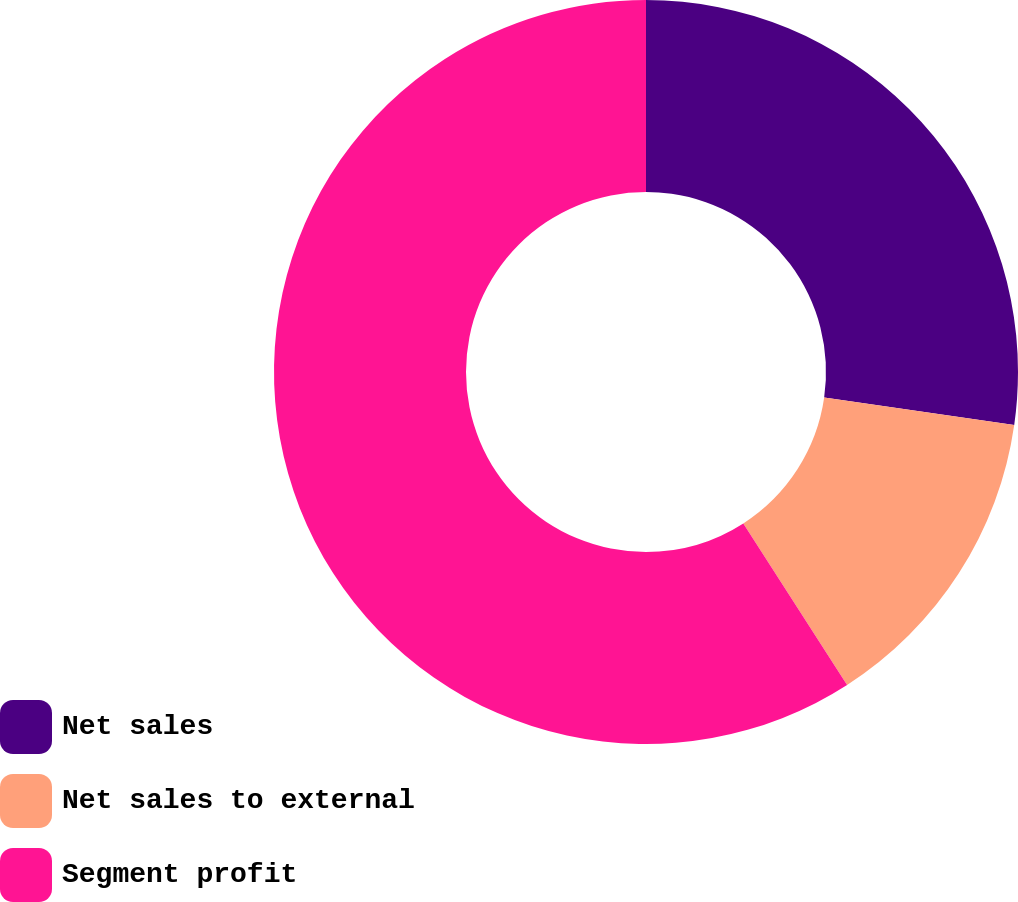Convert chart. <chart><loc_0><loc_0><loc_500><loc_500><pie_chart><fcel>Net sales<fcel>Net sales to external<fcel>Segment profit<nl><fcel>27.27%<fcel>13.64%<fcel>59.09%<nl></chart> 